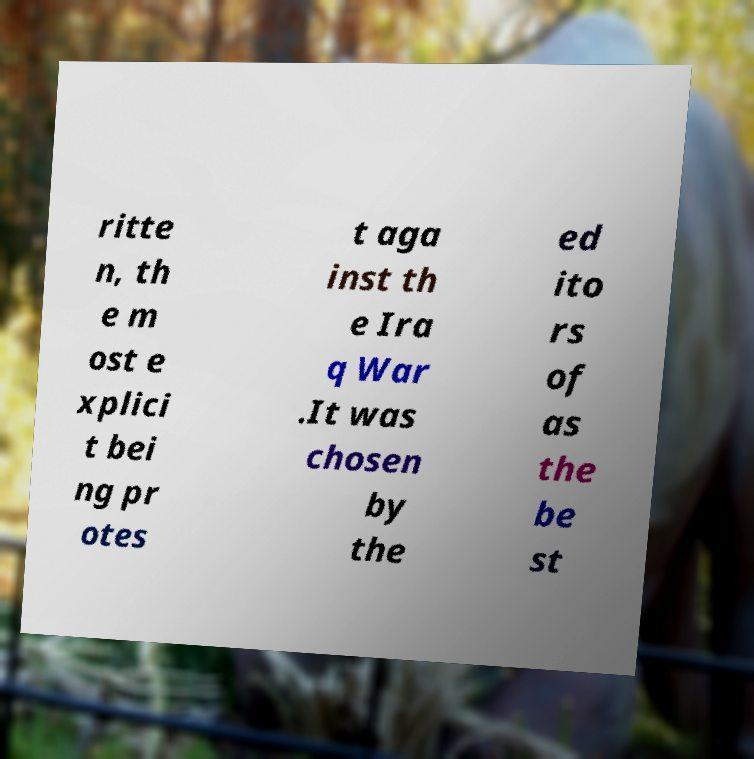There's text embedded in this image that I need extracted. Can you transcribe it verbatim? ritte n, th e m ost e xplici t bei ng pr otes t aga inst th e Ira q War .It was chosen by the ed ito rs of as the be st 